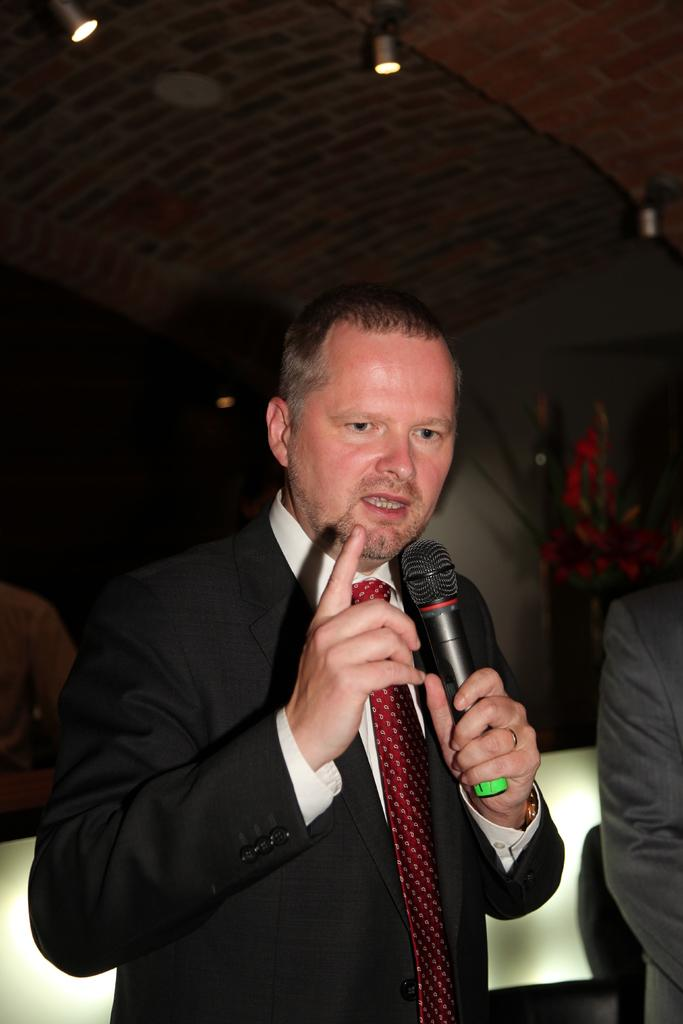What is: What is the person in the image doing? The person is standing and talking while holding a microphone. What object is the person holding in the image? The person is holding a microphone. What can be seen in the background of the image? There is a wall and a house plant in the background of the image. What is visible at the top of the image? There are lights visible at the top of the image. What date is marked on the calendar in the image? There is no calendar present in the image. What story is the person telling in the image? The image does not provide information about the content of the person's speech, so we cannot determine the story they are telling. 